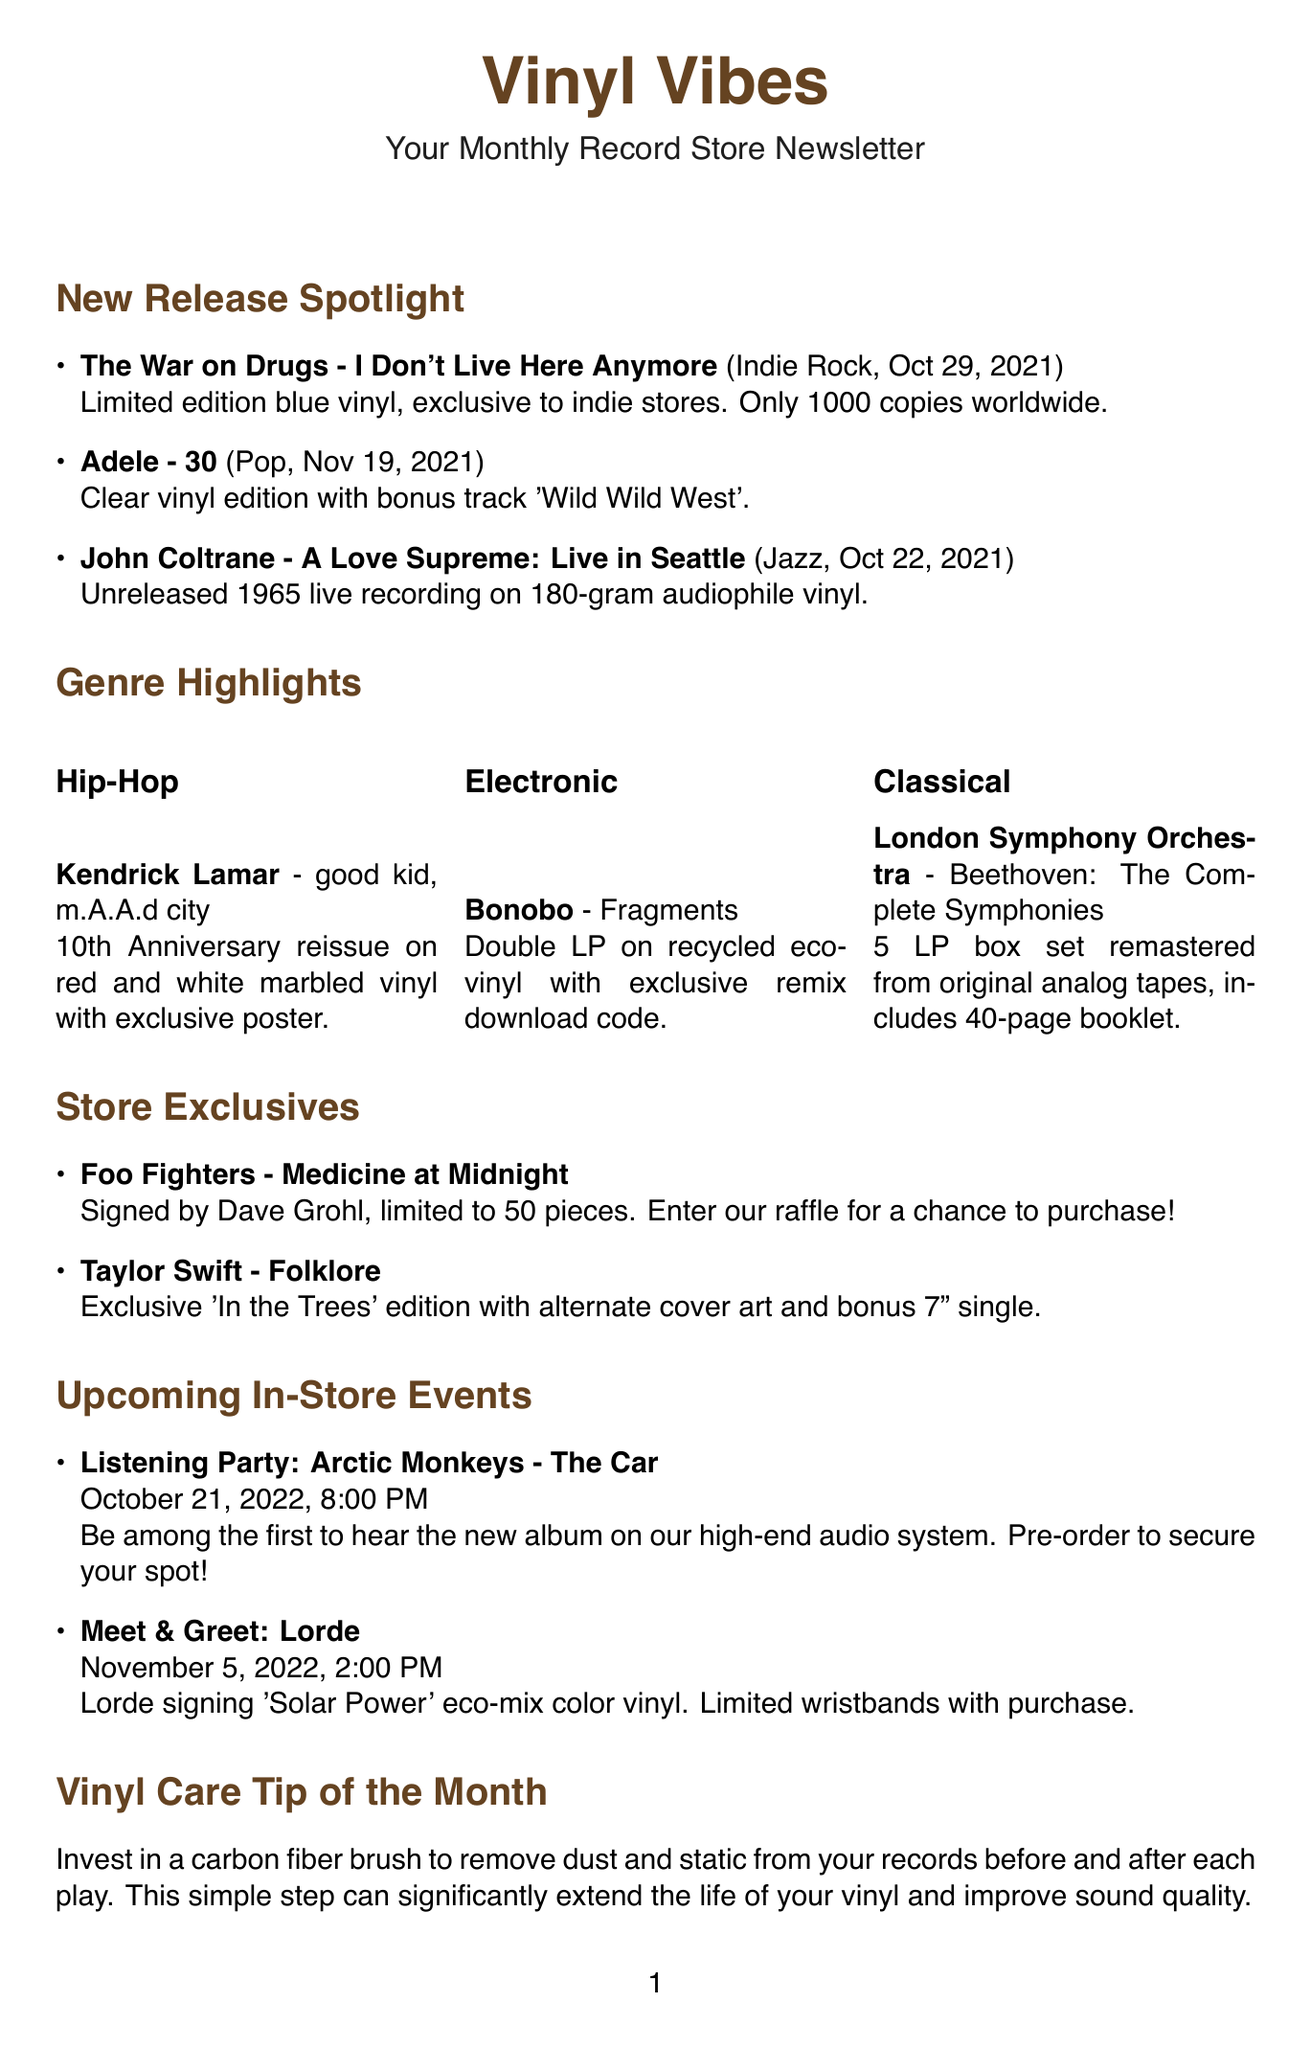What is the release date of "I Don't Live Here Anymore"? The release date is found in the New Release Spotlight section next to the album title.
Answer: October 29, 2021 How many copies of "I Don't Live Here Anymore" are available? The number of copies is specified in the description of the album.
Answer: 1000 Who is the artist for the exclusive edition of "Folklore"? The artist is mentioned in the Store Exclusives section.
Answer: Taylor Swift What type of vinyl is "good kid, m.A.A.d city" pressed on? The type of vinyl is referenced in the Genre Highlights section.
Answer: Red and white marbled What event is scheduled for October 21, 2022? The event is listed in the Upcoming In-Store Events section with the date and corresponding artist.
Answer: Listening Party What is the main benefit of the Customer Loyalty Program mentioned? The benefit is described in the Customer Loyalty Program section.
Answer: Earn $10 in store credit for every $100 spent What item comes with Bonobo's "Fragments"? The item included is stated in the description of the featured release.
Answer: Download code for exclusive remixes Which orchestral work is highlighted in the classical genre? The title of the work is included in the Genre Highlights section under Classical.
Answer: Beethoven: The Complete Symphonies 